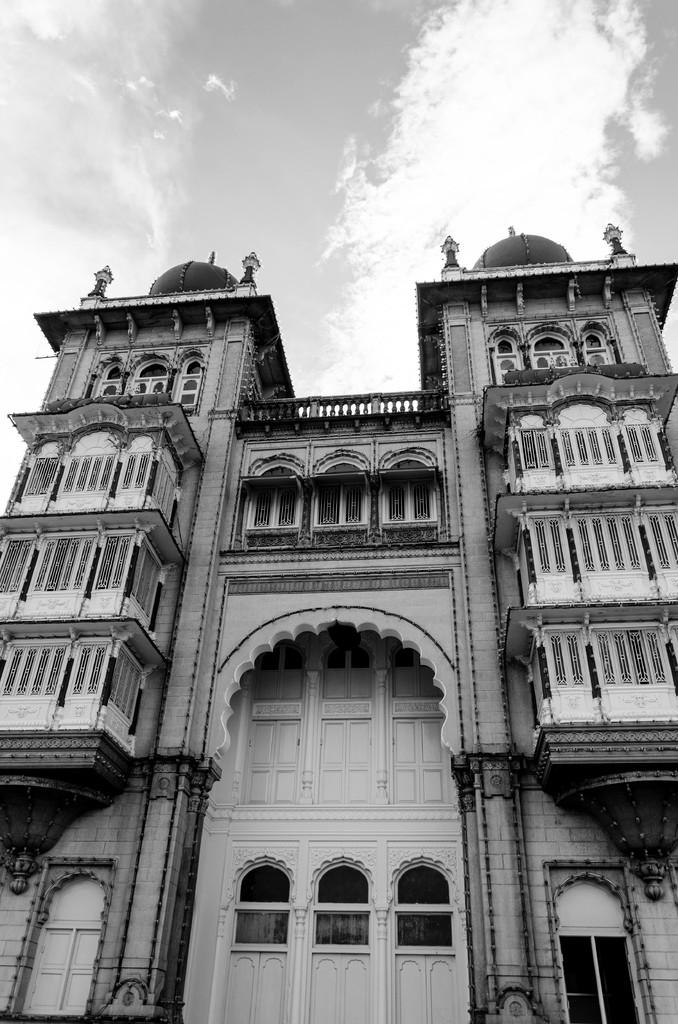What is the main subject in the foreground of the image? There is a building in the foreground of the image. What is the color scheme of the image? The image is black and white. What is visible at the top of the image? The sky is visible at the top of the image. Can you describe the sky in the image? There is a cloud in the sky. Where is the net located in the image? There is no net present in the image. What type of roll can be seen in the image? There is no roll present in the image. 